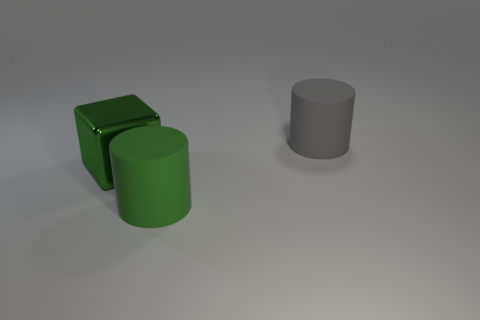Add 2 rubber blocks. How many objects exist? 5 Subtract all blocks. How many objects are left? 2 Add 1 green shiny things. How many green shiny things exist? 2 Subtract 0 blue cylinders. How many objects are left? 3 Subtract all tiny brown metal objects. Subtract all matte cylinders. How many objects are left? 1 Add 1 metal cubes. How many metal cubes are left? 2 